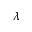<formula> <loc_0><loc_0><loc_500><loc_500>\lambda</formula> 